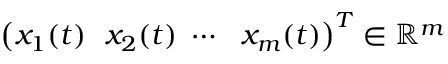<formula> <loc_0><loc_0><loc_500><loc_500>\left ( x _ { 1 } ( t ) \ \ x _ { 2 } ( t ) \ \cdots \ \ x _ { m } ( t ) \right ) ^ { T } \in \mathbb { R } ^ { m }</formula> 